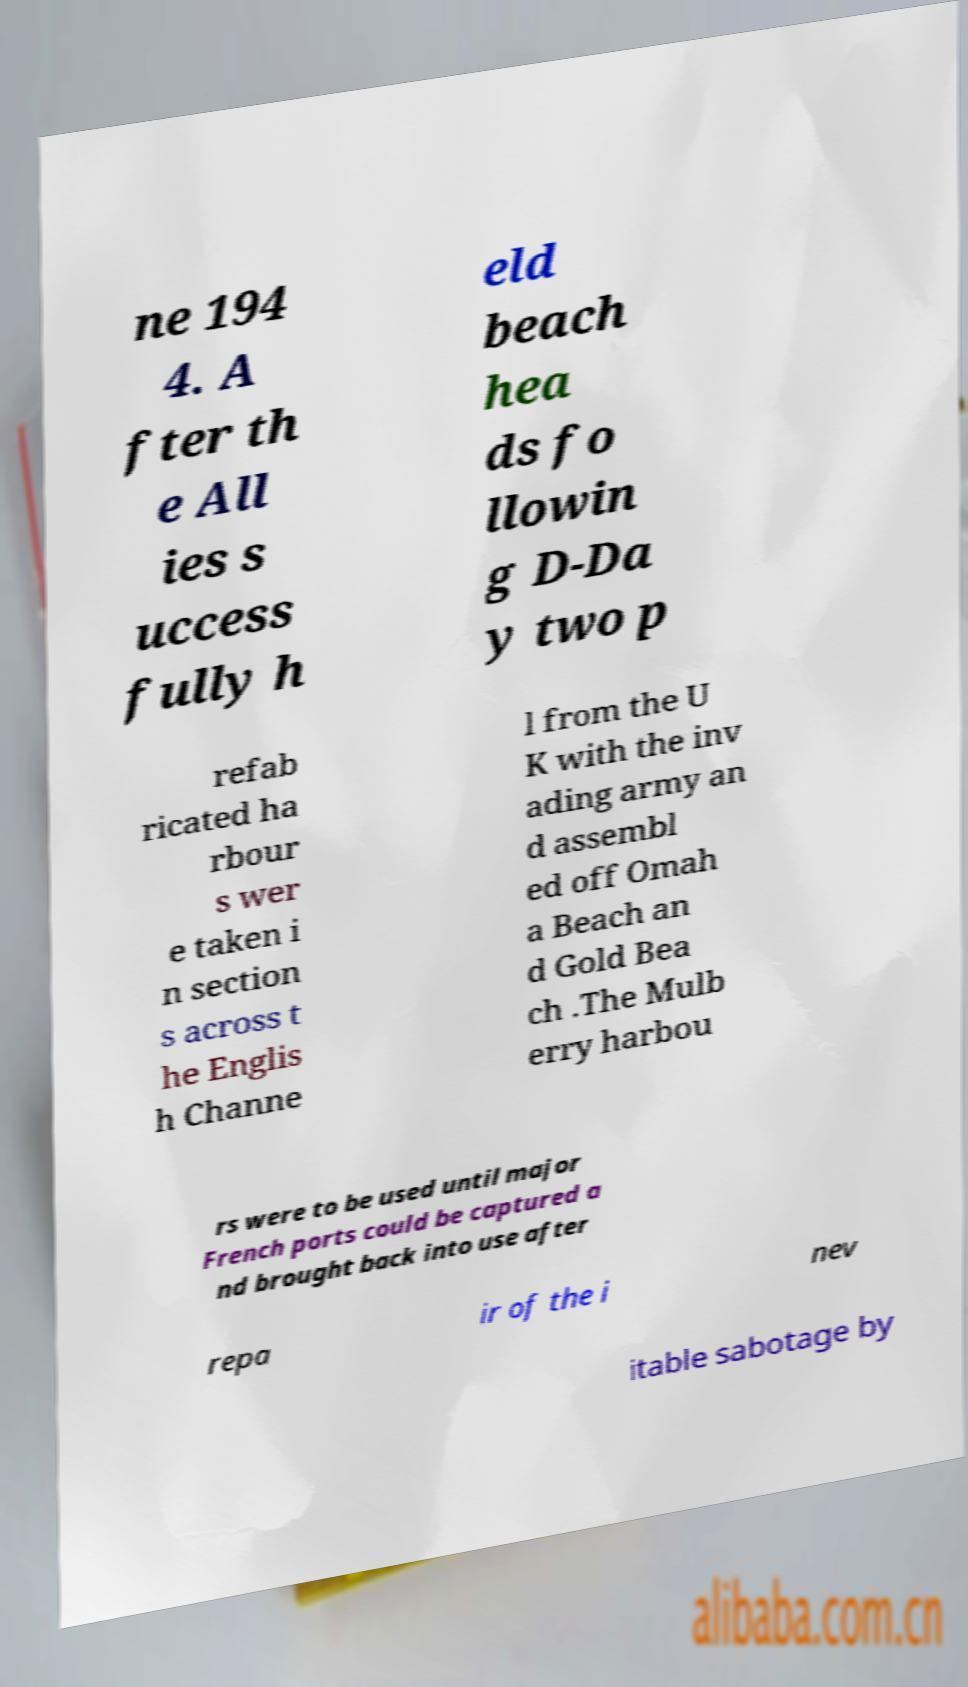What messages or text are displayed in this image? I need them in a readable, typed format. ne 194 4. A fter th e All ies s uccess fully h eld beach hea ds fo llowin g D-Da y two p refab ricated ha rbour s wer e taken i n section s across t he Englis h Channe l from the U K with the inv ading army an d assembl ed off Omah a Beach an d Gold Bea ch .The Mulb erry harbou rs were to be used until major French ports could be captured a nd brought back into use after repa ir of the i nev itable sabotage by 